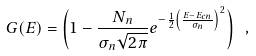Convert formula to latex. <formula><loc_0><loc_0><loc_500><loc_500>G ( E ) = \left ( 1 - \frac { N _ { n } } { \sigma _ { n } \sqrt { 2 \pi } } e ^ { - \frac { 1 } { 2 } { \left ( \frac { E - E _ { c n } } { \sigma _ { n } } \right ) } ^ { 2 } } \right ) \ ,</formula> 